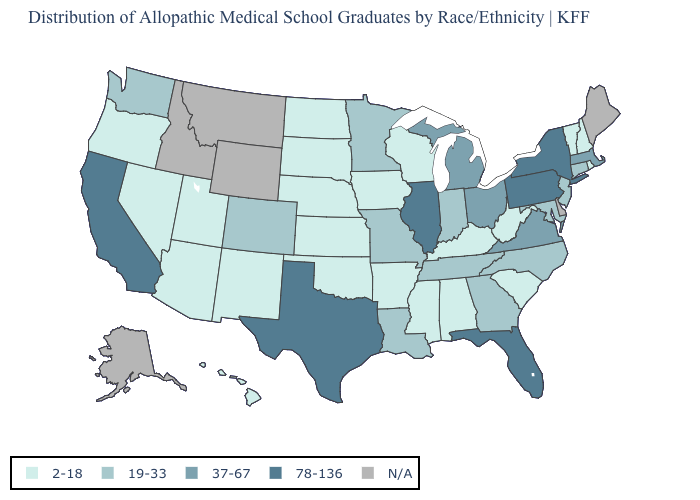What is the highest value in the USA?
Write a very short answer. 78-136. What is the highest value in states that border Maryland?
Concise answer only. 78-136. Which states have the lowest value in the USA?
Quick response, please. Alabama, Arizona, Arkansas, Hawaii, Iowa, Kansas, Kentucky, Mississippi, Nebraska, Nevada, New Hampshire, New Mexico, North Dakota, Oklahoma, Oregon, Rhode Island, South Carolina, South Dakota, Utah, Vermont, West Virginia, Wisconsin. What is the value of Connecticut?
Short answer required. 19-33. Does the map have missing data?
Give a very brief answer. Yes. Name the states that have a value in the range 19-33?
Concise answer only. Colorado, Connecticut, Georgia, Indiana, Louisiana, Maryland, Minnesota, Missouri, New Jersey, North Carolina, Tennessee, Washington. Does Georgia have the lowest value in the USA?
Give a very brief answer. No. Does West Virginia have the lowest value in the USA?
Quick response, please. Yes. What is the highest value in the USA?
Concise answer only. 78-136. Name the states that have a value in the range 19-33?
Short answer required. Colorado, Connecticut, Georgia, Indiana, Louisiana, Maryland, Minnesota, Missouri, New Jersey, North Carolina, Tennessee, Washington. Name the states that have a value in the range 19-33?
Concise answer only. Colorado, Connecticut, Georgia, Indiana, Louisiana, Maryland, Minnesota, Missouri, New Jersey, North Carolina, Tennessee, Washington. Which states have the lowest value in the USA?
Give a very brief answer. Alabama, Arizona, Arkansas, Hawaii, Iowa, Kansas, Kentucky, Mississippi, Nebraska, Nevada, New Hampshire, New Mexico, North Dakota, Oklahoma, Oregon, Rhode Island, South Carolina, South Dakota, Utah, Vermont, West Virginia, Wisconsin. Name the states that have a value in the range 78-136?
Short answer required. California, Florida, Illinois, New York, Pennsylvania, Texas. Name the states that have a value in the range 2-18?
Concise answer only. Alabama, Arizona, Arkansas, Hawaii, Iowa, Kansas, Kentucky, Mississippi, Nebraska, Nevada, New Hampshire, New Mexico, North Dakota, Oklahoma, Oregon, Rhode Island, South Carolina, South Dakota, Utah, Vermont, West Virginia, Wisconsin. 